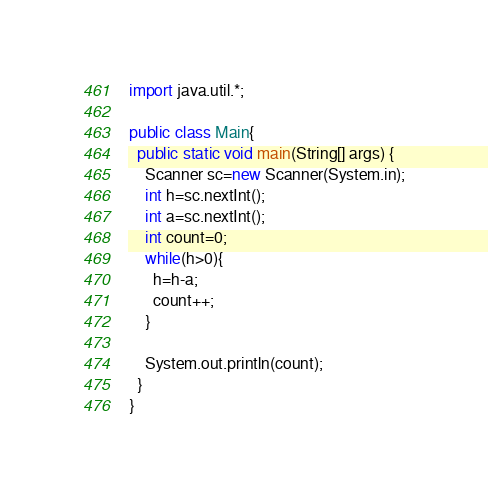<code> <loc_0><loc_0><loc_500><loc_500><_Java_>import java.util.*;

public class Main{
  public static void main(String[] args) {
    Scanner sc=new Scanner(System.in);
    int h=sc.nextInt();
    int a=sc.nextInt();
    int count=0;
    while(h>0){
      h=h-a;
      count++;
    }

    System.out.println(count);
  }
}
</code> 